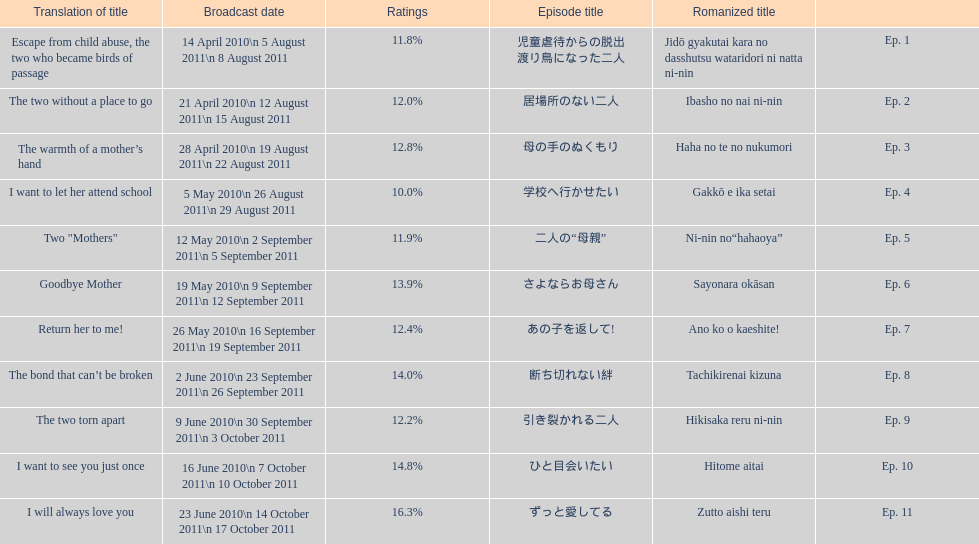How many episode are not over 14%? 8. 